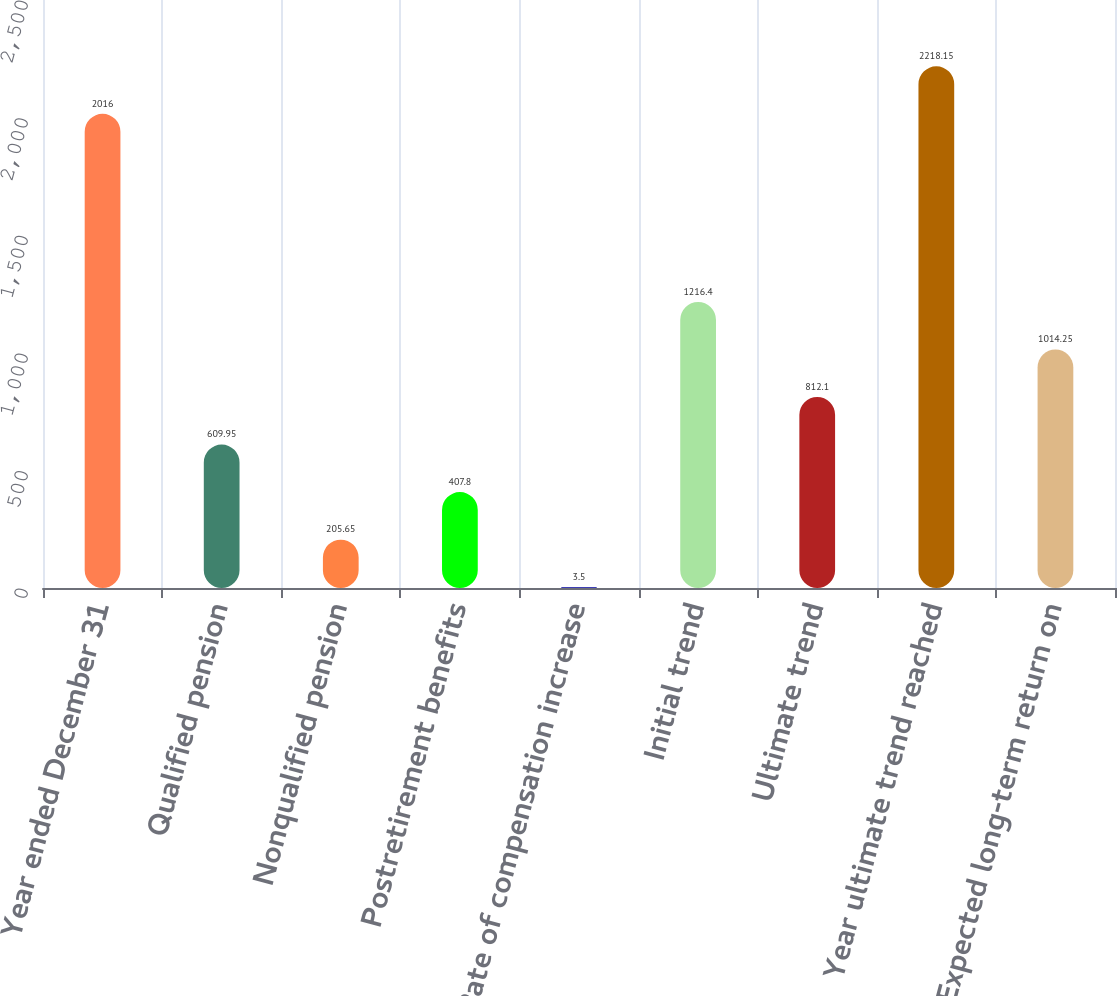Convert chart to OTSL. <chart><loc_0><loc_0><loc_500><loc_500><bar_chart><fcel>Year ended December 31<fcel>Qualified pension<fcel>Nonqualified pension<fcel>Postretirement benefits<fcel>Rate of compensation increase<fcel>Initial trend<fcel>Ultimate trend<fcel>Year ultimate trend reached<fcel>Expected long-term return on<nl><fcel>2016<fcel>609.95<fcel>205.65<fcel>407.8<fcel>3.5<fcel>1216.4<fcel>812.1<fcel>2218.15<fcel>1014.25<nl></chart> 